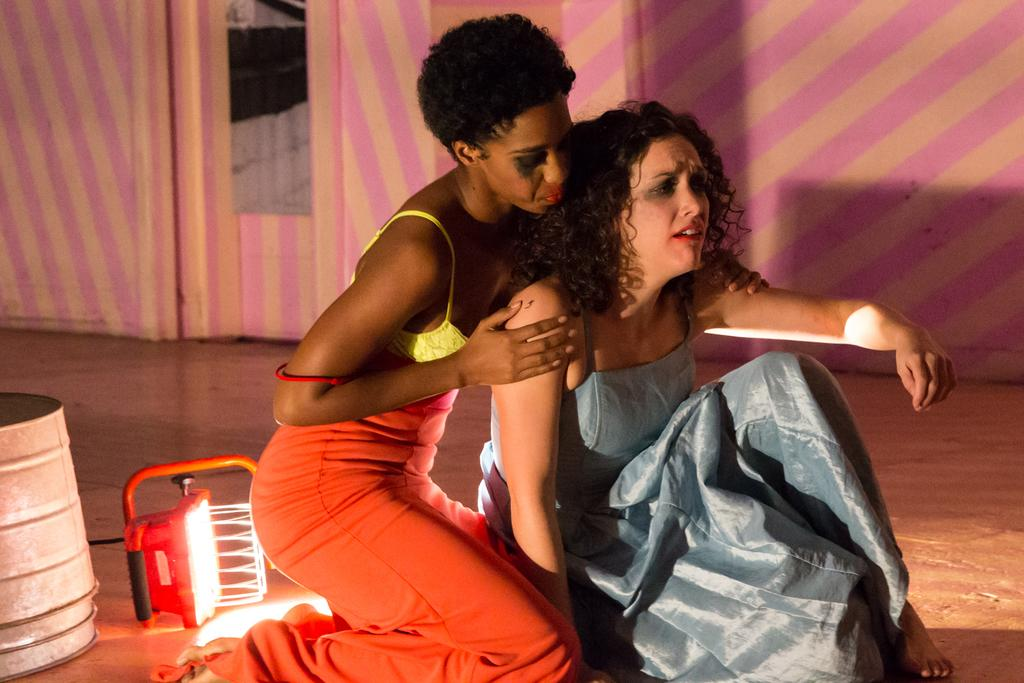What are the women in the image doing? The women are sitting on the floor in the image. What can be seen in the background of the image? There are walls, bins, and an electric light in the background of the image. What type of celery is being used as a prop in the image? There is no celery present in the image. What kind of business is being conducted in the image? The image does not depict any business activities. 